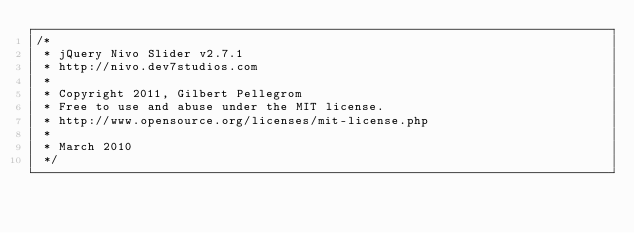Convert code to text. <code><loc_0><loc_0><loc_500><loc_500><_JavaScript_>/*
 * jQuery Nivo Slider v2.7.1
 * http://nivo.dev7studios.com
 *
 * Copyright 2011, Gilbert Pellegrom
 * Free to use and abuse under the MIT license.
 * http://www.opensource.org/licenses/mit-license.php
 * 
 * March 2010
 */
</code> 